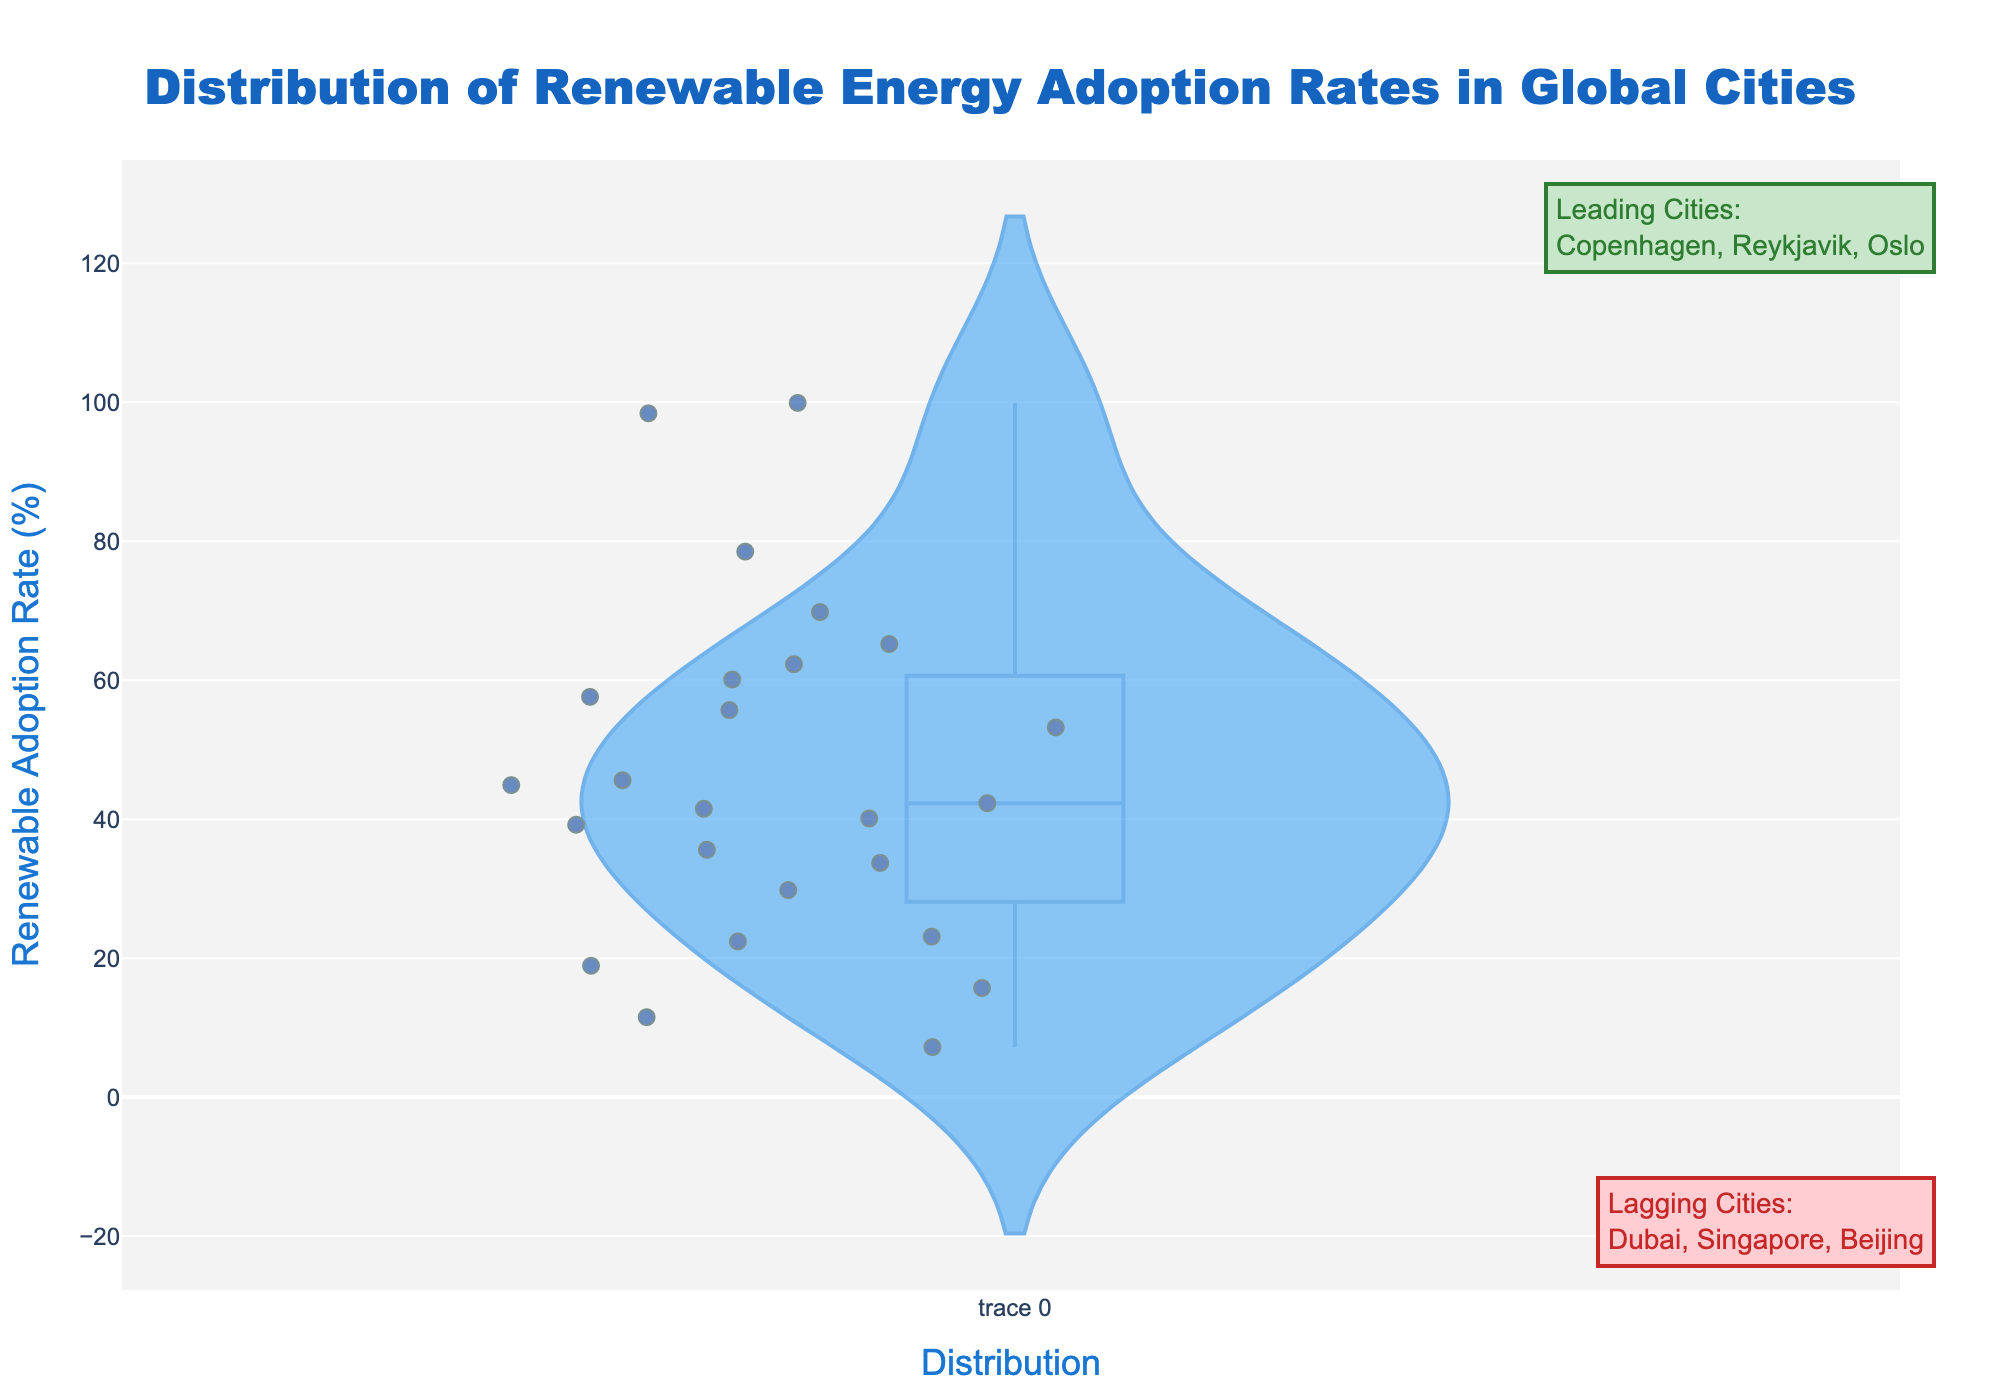What is the title of the density plot? The title is prominently displayed at the top of the plot. It provides a brief description of what the plot is about.
Answer: 'Distribution of Renewable Energy Adoption Rates in Global Cities' What is the renewable energy adoption rate for Reykjavik? To find Reykjavik's adoption rate, locate its data point in the plot, which is easier by checking the hover template or the point label.
Answer: 99.9% Which cities are leading in renewable energy adoption? The leading cities are listed in the annotation box on the top-right side of the plot.
Answer: Copenhagen, Reykjavik, Oslo How many cities have a renewable energy adoption rate below 20%? Examine the plot to identify and count the cities with their data points falling below the 20% mark. Use the hover template for precise identification.
Answer: 4 cities What is the difference in adoption rate between the leading city and the lagging city? Identify the highest rate (Reykjavik) and the lowest rate (Dubai) from the plot, then calculate the difference (99.9% - 7.2%).
Answer: 92.7% Among Sydney, Paris, and Tokyo, which city has the highest adoption rate? Compare the adoption rates for each of these cities by looking at their respective data points on the plot.
Answer: Sydney How does the renewable energy adoption rate of Vancouver compare to that of Amsterdam? Locate and compare the data points for Vancouver and Amsterdam on the plot.
Answer: Vancouver's rate is slightly lower than Amsterdam's (60.1% vs. 62.3%) Is there a clear distinction between leading cities and lagging cities in terms of renewable energy adoption rates? Observe the distribution and spread of adoption rates in the plot; consider the annotations highlighting top and bottom cities.
Answer: Yes, there is a clear distinction What does the annotation box at the bottom right indicate? Read the content of the annotation box at the bottom right; it lists the cities with the lowest renewable energy adoption rates.
Answer: Lagging Cities: Dubai, Singapore, Beijing Which city has a renewable adoption rate closest to the median value of all cities? Estimate the median by observing the central tendency of the data spread, then match it with the nearest city data point.
Answer: Stockholm 